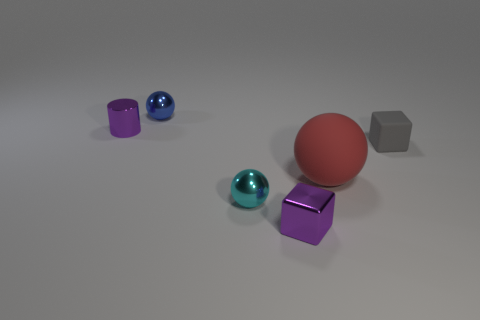Add 3 shiny blocks. How many objects exist? 9 Subtract all tiny metal balls. How many balls are left? 1 Subtract all blocks. How many objects are left? 4 Subtract all small purple metal cylinders. Subtract all small cyan balls. How many objects are left? 4 Add 5 small gray matte cubes. How many small gray matte cubes are left? 6 Add 6 red rubber objects. How many red rubber objects exist? 7 Subtract 0 brown blocks. How many objects are left? 6 Subtract all brown cylinders. Subtract all green blocks. How many cylinders are left? 1 